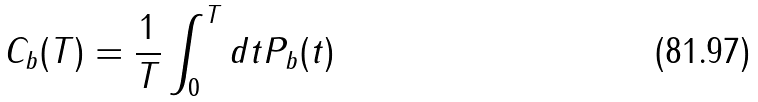<formula> <loc_0><loc_0><loc_500><loc_500>C _ { b } ( T ) = \frac { 1 } { T } \int _ { 0 } ^ { T } d t P _ { b } ( t )</formula> 